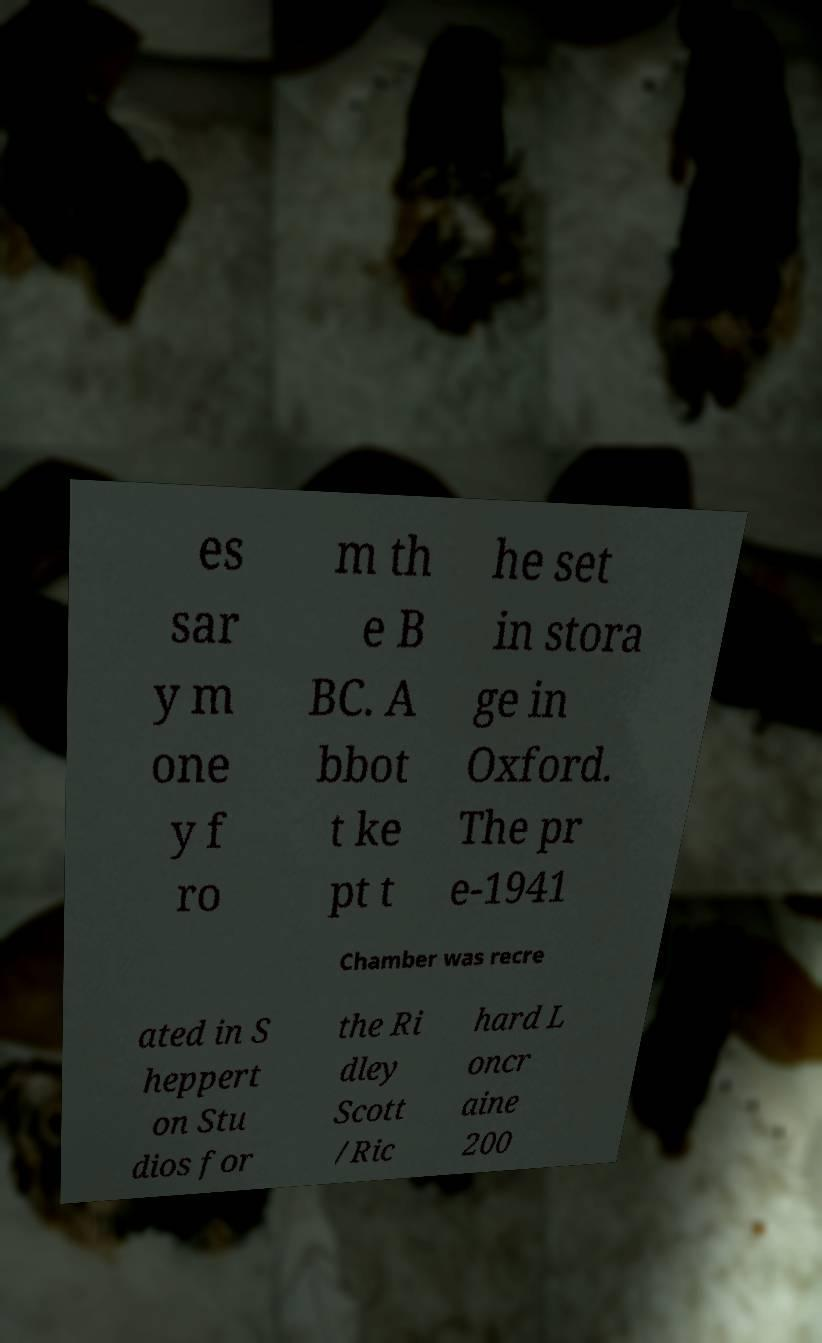For documentation purposes, I need the text within this image transcribed. Could you provide that? es sar y m one y f ro m th e B BC. A bbot t ke pt t he set in stora ge in Oxford. The pr e-1941 Chamber was recre ated in S heppert on Stu dios for the Ri dley Scott /Ric hard L oncr aine 200 